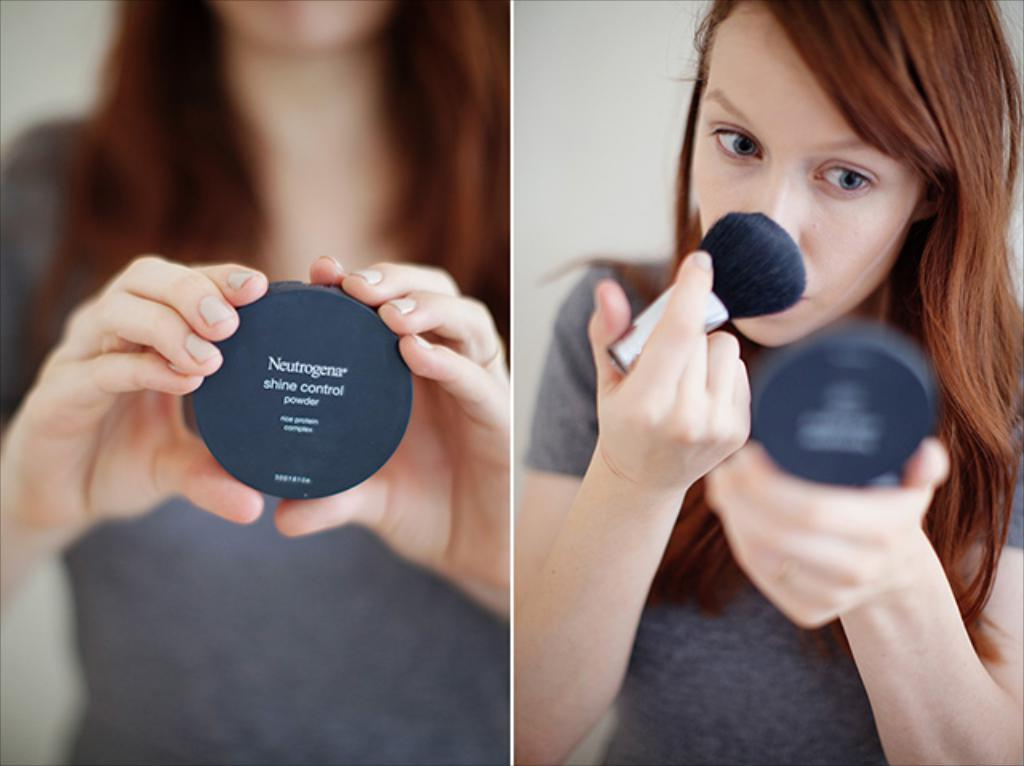<image>
Share a concise interpretation of the image provided. A woman putting makeup on her face that is from the company of Neutrogena. 